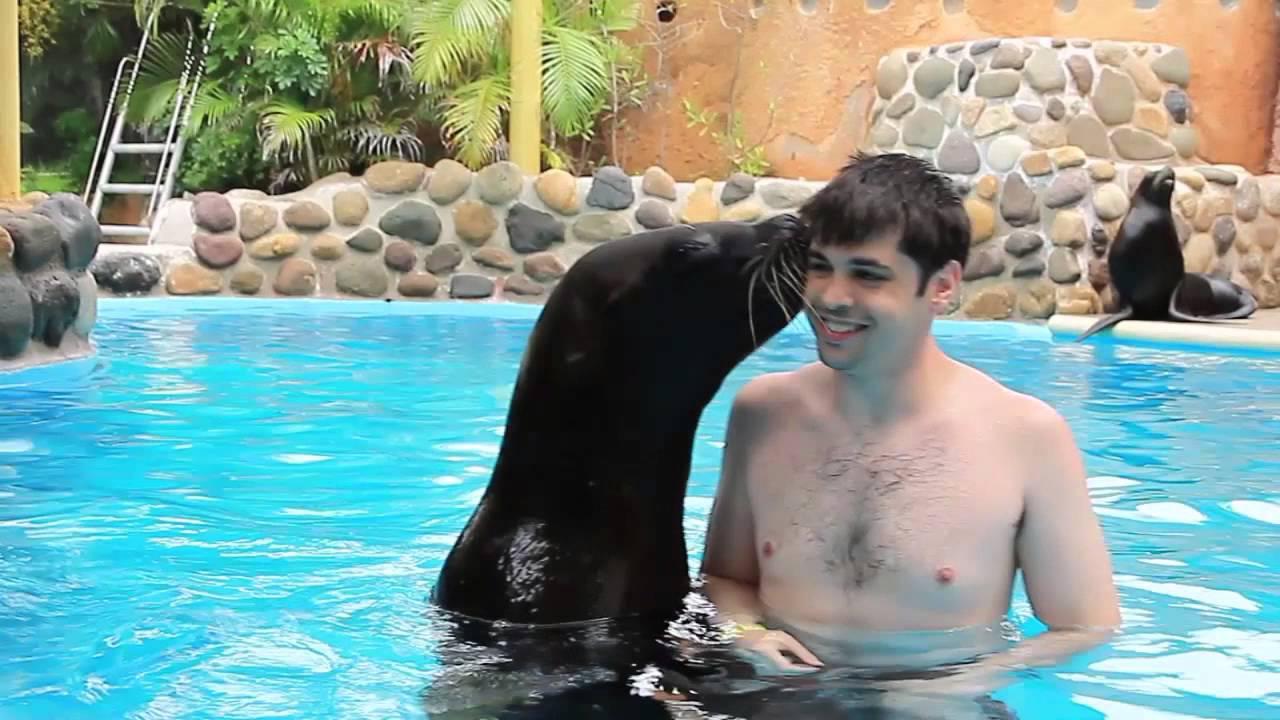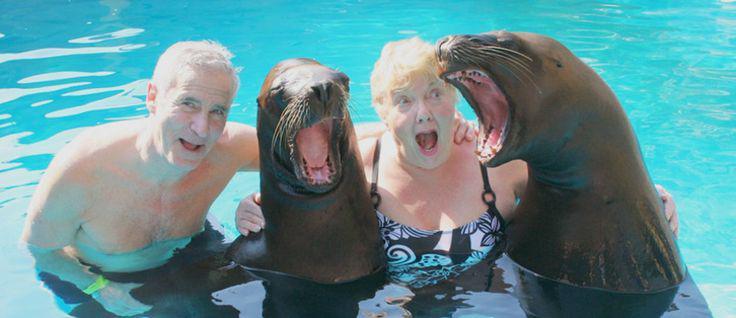The first image is the image on the left, the second image is the image on the right. Considering the images on both sides, is "Two people are in the water with two sea animals in one of the pictures." valid? Answer yes or no. Yes. The first image is the image on the left, the second image is the image on the right. Assess this claim about the two images: "The right image includes twice the number of people and seals in the foreground as the left image.". Correct or not? Answer yes or no. Yes. 